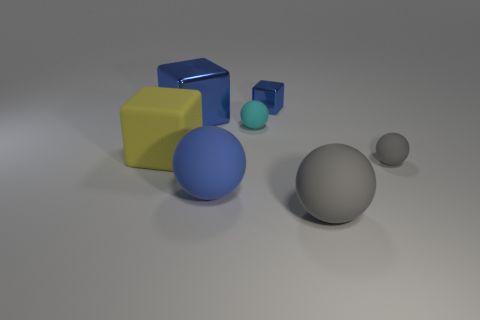Is the big matte block the same color as the small shiny cube?
Provide a succinct answer. No. What number of things are either big yellow cubes that are left of the tiny cyan ball or small brown shiny cubes?
Provide a succinct answer. 1. There is a big block right of the yellow matte cube that is in front of the tiny cyan sphere; how many blue things are right of it?
Your answer should be very brief. 2. Is there anything else that is the same size as the cyan object?
Provide a short and direct response. Yes. There is a large matte thing on the left side of the big cube that is on the right side of the large yellow matte object that is on the left side of the tiny cyan sphere; what shape is it?
Your response must be concise. Cube. How many other objects are there of the same color as the large rubber cube?
Your answer should be compact. 0. The blue object in front of the small thing in front of the tiny cyan object is what shape?
Your response must be concise. Sphere. There is a large blue matte object; how many big things are in front of it?
Your response must be concise. 1. Are there any large blue things made of the same material as the tiny blue object?
Ensure brevity in your answer.  Yes. There is a gray thing that is the same size as the cyan rubber ball; what material is it?
Offer a very short reply. Rubber. 